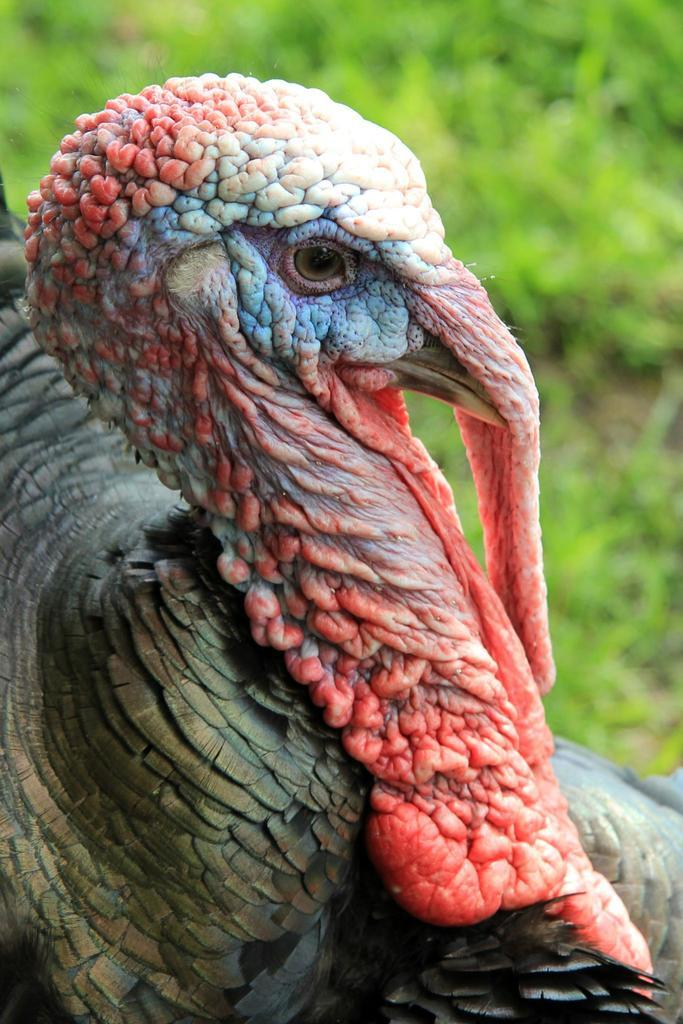What type of animal is present in the image? There is a bird in the image. What role does the daughter play in the image? There is no daughter present in the image, as it only features a bird. 